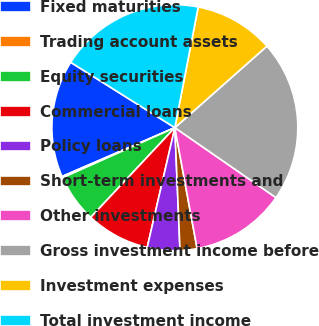Convert chart to OTSL. <chart><loc_0><loc_0><loc_500><loc_500><pie_chart><fcel>Fixed maturities<fcel>Trading account assets<fcel>Equity securities<fcel>Commercial loans<fcel>Policy loans<fcel>Short-term investments and<fcel>Other investments<fcel>Gross investment income before<fcel>Investment expenses<fcel>Total investment income<nl><fcel>15.42%<fcel>0.18%<fcel>6.33%<fcel>8.38%<fcel>4.28%<fcel>2.23%<fcel>12.47%<fcel>21.17%<fcel>10.43%<fcel>19.12%<nl></chart> 